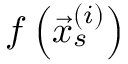Convert formula to latex. <formula><loc_0><loc_0><loc_500><loc_500>f \left ( \vec { x } _ { s } ^ { ( i ) } \right )</formula> 